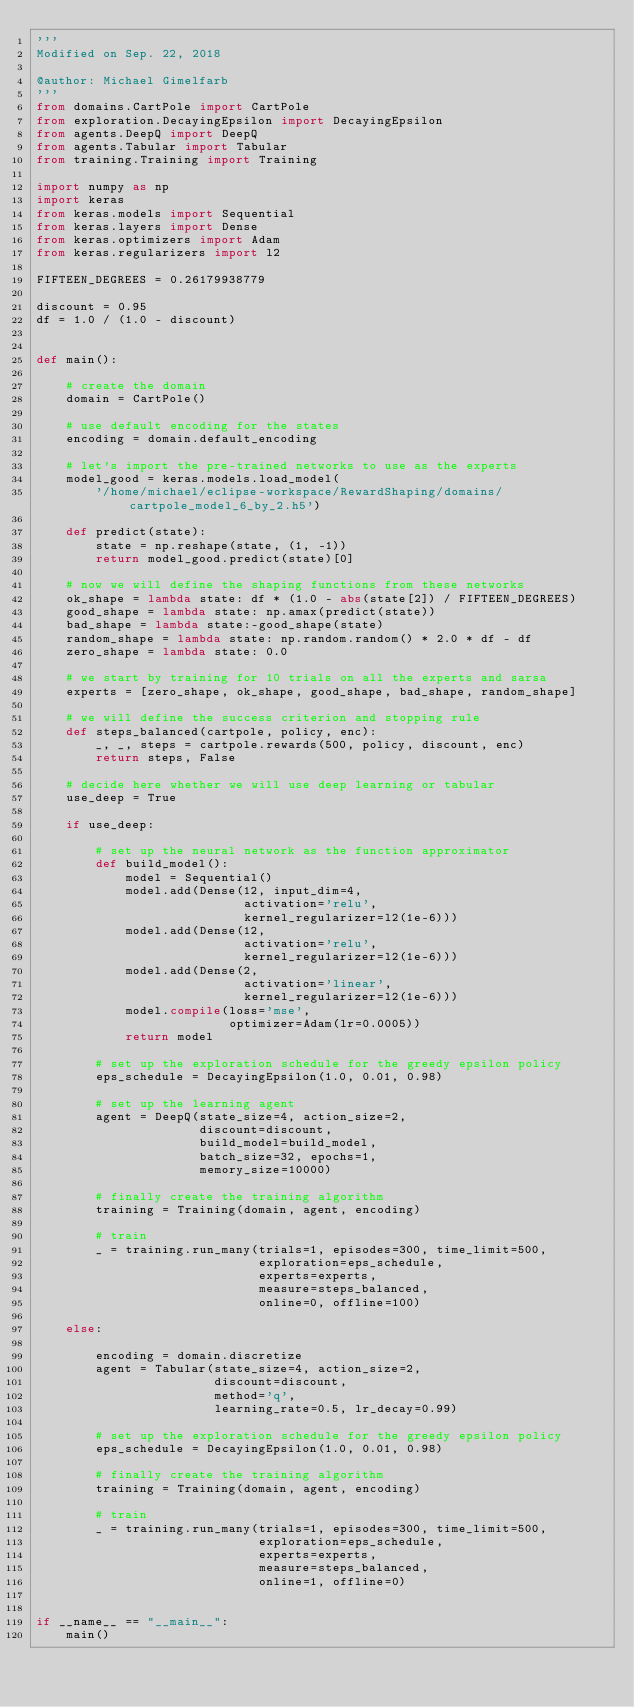Convert code to text. <code><loc_0><loc_0><loc_500><loc_500><_Python_>'''
Modified on Sep. 22, 2018

@author: Michael Gimelfarb
'''
from domains.CartPole import CartPole
from exploration.DecayingEpsilon import DecayingEpsilon
from agents.DeepQ import DeepQ
from agents.Tabular import Tabular
from training.Training import Training

import numpy as np
import keras
from keras.models import Sequential
from keras.layers import Dense
from keras.optimizers import Adam
from keras.regularizers import l2

FIFTEEN_DEGREES = 0.26179938779

discount = 0.95
df = 1.0 / (1.0 - discount)


def main():
    
    # create the domain
    domain = CartPole()

    # use default encoding for the states
    encoding = domain.default_encoding

    # let's import the pre-trained networks to use as the experts
    model_good = keras.models.load_model(
        '/home/michael/eclipse-workspace/RewardShaping/domains/cartpole_model_6_by_2.h5')
    
    def predict(state):
        state = np.reshape(state, (1, -1))
        return model_good.predict(state)[0]

    # now we will define the shaping functions from these networks
    ok_shape = lambda state: df * (1.0 - abs(state[2]) / FIFTEEN_DEGREES)
    good_shape = lambda state: np.amax(predict(state))
    bad_shape = lambda state:-good_shape(state)
    random_shape = lambda state: np.random.random() * 2.0 * df - df
    zero_shape = lambda state: 0.0

    # we start by training for 10 trials on all the experts and sarsa
    experts = [zero_shape, ok_shape, good_shape, bad_shape, random_shape]

    # we will define the success criterion and stopping rule
    def steps_balanced(cartpole, policy, enc):
        _, _, steps = cartpole.rewards(500, policy, discount, enc)
        return steps, False

    # decide here whether we will use deep learning or tabular
    use_deep = True
    
    if use_deep:

        # set up the neural network as the function approximator
        def build_model():
            model = Sequential()
            model.add(Dense(12, input_dim=4,
                            activation='relu',
                            kernel_regularizer=l2(1e-6)))
            model.add(Dense(12,
                            activation='relu',
                            kernel_regularizer=l2(1e-6)))
            model.add(Dense(2,
                            activation='linear',
                            kernel_regularizer=l2(1e-6)))
            model.compile(loss='mse',
                          optimizer=Adam(lr=0.0005))
            return model

        # set up the exploration schedule for the greedy epsilon policy
        eps_schedule = DecayingEpsilon(1.0, 0.01, 0.98)

        # set up the learning agent
        agent = DeepQ(state_size=4, action_size=2,
                      discount=discount,
                      build_model=build_model,
                      batch_size=32, epochs=1,
                      memory_size=10000)
        
        # finally create the training algorithm
        training = Training(domain, agent, encoding)
    
        # train
        _ = training.run_many(trials=1, episodes=300, time_limit=500,
                              exploration=eps_schedule,
                              experts=experts,
                              measure=steps_balanced,
                              online=0, offline=100)
        
    else:
        
        encoding = domain.discretize
        agent = Tabular(state_size=4, action_size=2,
                        discount=discount,
                        method='q',
                        learning_rate=0.5, lr_decay=0.99)

        # set up the exploration schedule for the greedy epsilon policy
        eps_schedule = DecayingEpsilon(1.0, 0.01, 0.98)
        
        # finally create the training algorithm
        training = Training(domain, agent, encoding)
    
        # train
        _ = training.run_many(trials=1, episodes=300, time_limit=500,
                              exploration=eps_schedule,
                              experts=experts,
                              measure=steps_balanced,
                              online=1, offline=0)


if __name__ == "__main__":
    main()
</code> 